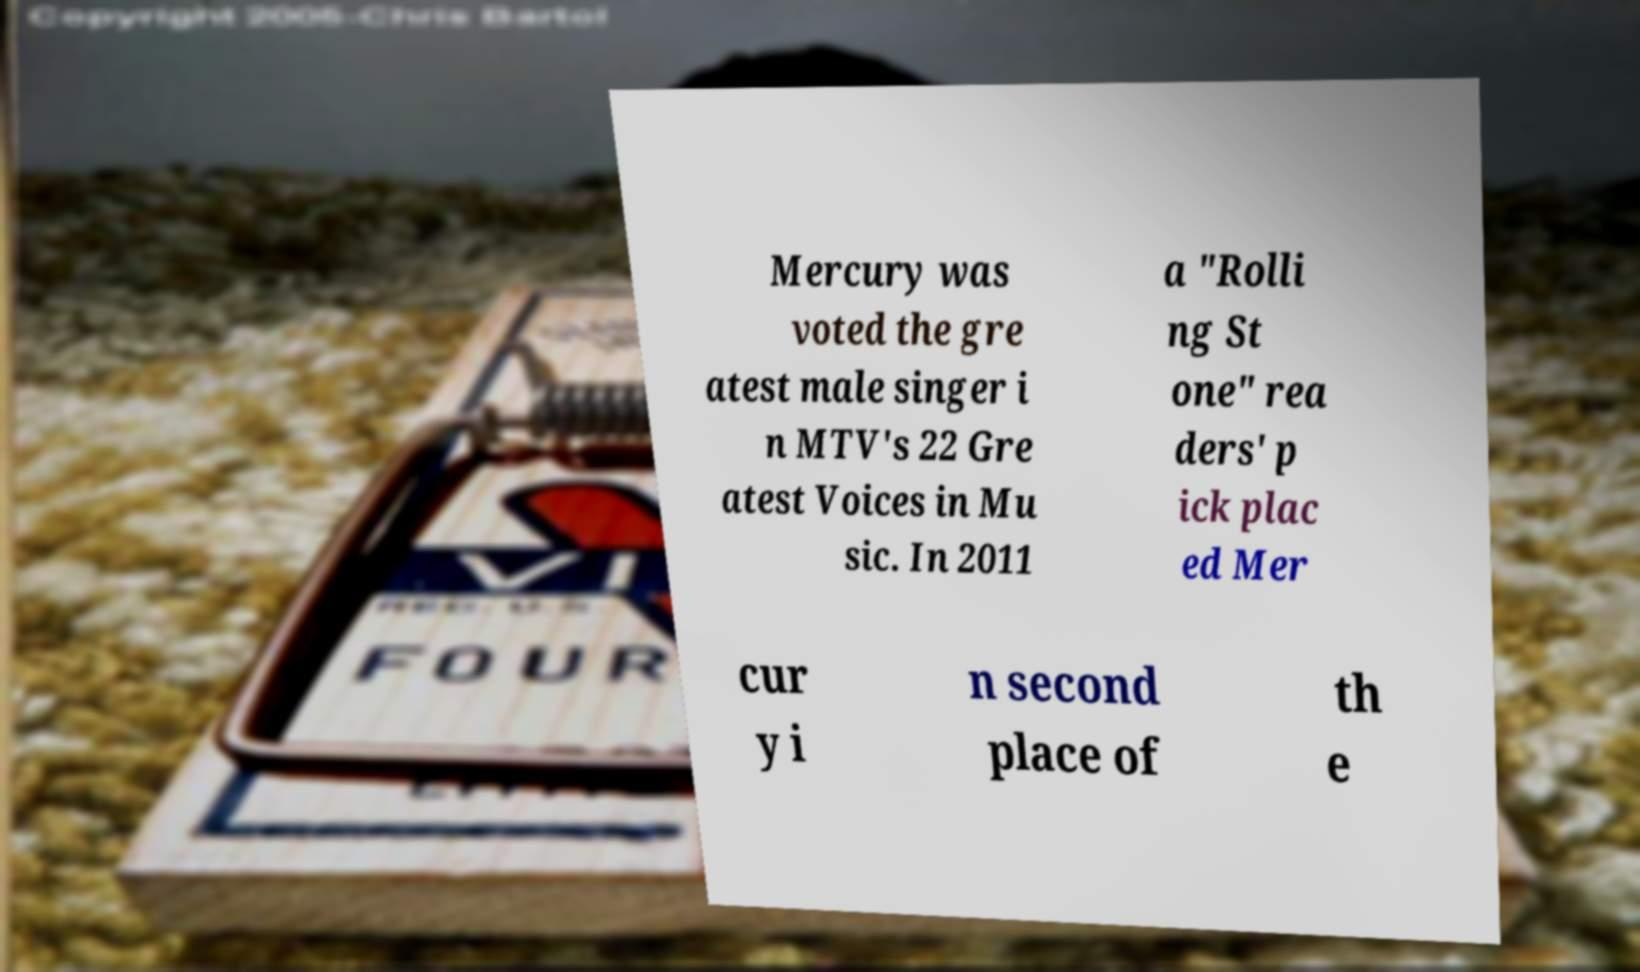Can you read and provide the text displayed in the image?This photo seems to have some interesting text. Can you extract and type it out for me? Mercury was voted the gre atest male singer i n MTV's 22 Gre atest Voices in Mu sic. In 2011 a "Rolli ng St one" rea ders' p ick plac ed Mer cur y i n second place of th e 